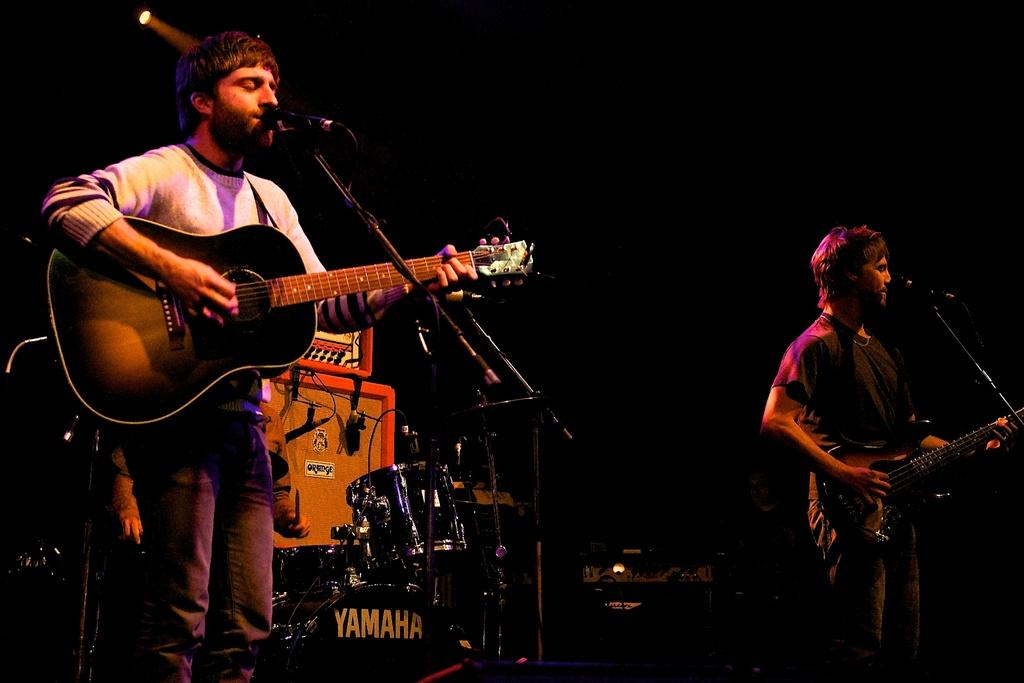How many people are in the image? There are two persons in the image. What are the persons doing in the image? The persons are standing and holding a guitar. What object is present for amplifying sound in the image? There is a mic in the image. What is used to support the mic in the image? There is a stand in the image. What other musical instruments can be seen in the image? There are musical instruments at the back side of the image. How many copies of the expert's book are visible in the image? There is no expert or book present in the image. What type of crowd can be seen in the image? There is no crowd present in the image; it features two persons holding a guitar and other musical instruments. 